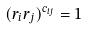<formula> <loc_0><loc_0><loc_500><loc_500>( r _ { i } r _ { j } ) ^ { c _ { i j } } = 1</formula> 